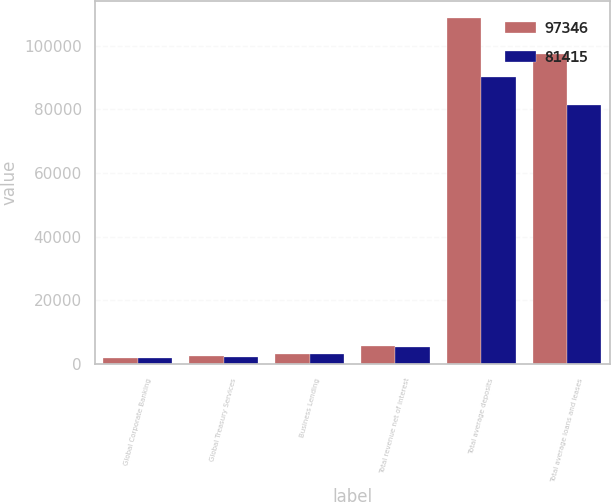Convert chart to OTSL. <chart><loc_0><loc_0><loc_500><loc_500><stacked_bar_chart><ecel><fcel>Global Corporate Banking<fcel>Global Treasury Services<fcel>Business Lending<fcel>Total revenue net of interest<fcel>Total average deposits<fcel>Total average loans and leases<nl><fcel>97346<fcel>2011<fcel>2448<fcel>3092<fcel>5540<fcel>108663<fcel>97346<nl><fcel>81415<fcel>2010<fcel>2259<fcel>3272<fcel>5531<fcel>90083<fcel>81415<nl></chart> 